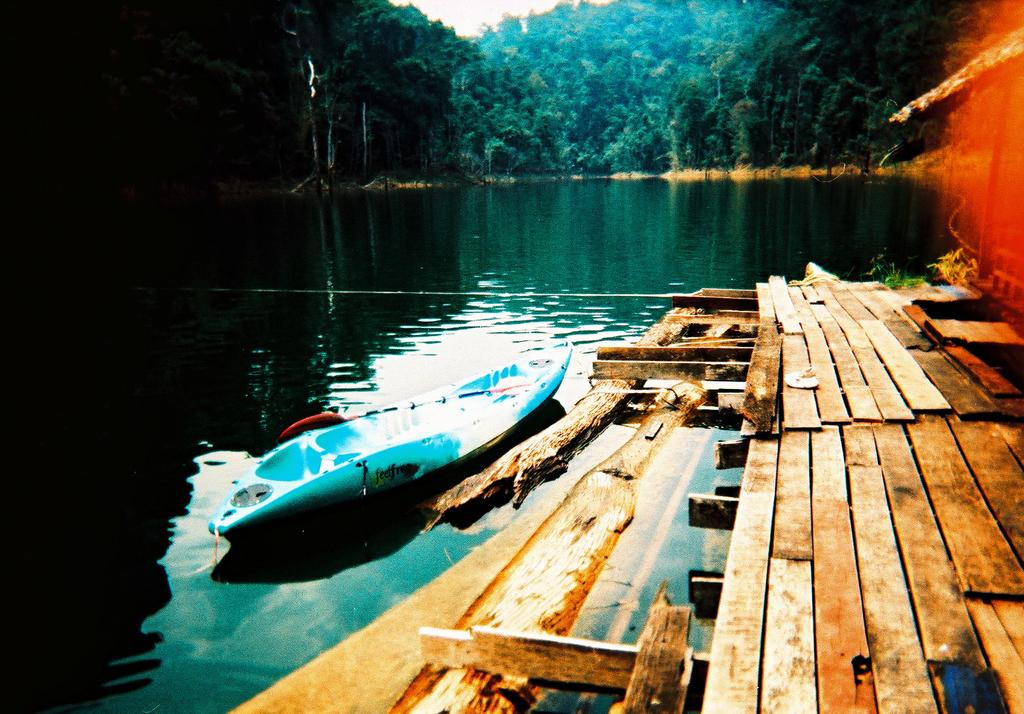What type of surface is visible in the image? There is a wooden surface in the image. What is the main object in the image? There is a boat in the image. What colors are used for the boat? The boat is white and blue in color. What can be seen in the background of the image? There are many trees and the sky visible in the background of the image. What type of company is represented by the boat in the image? There is no indication of a company in the image; it simply features a white and blue boat. What role does air play in the boat's movement in the image? The boat is not moving in the image, so air does not play a role in its movement. 